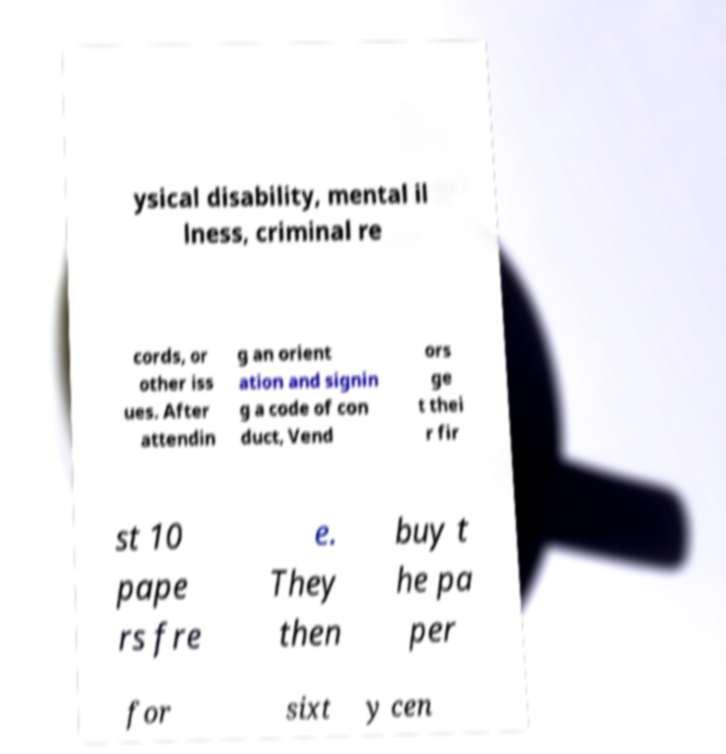I need the written content from this picture converted into text. Can you do that? ysical disability, mental il lness, criminal re cords, or other iss ues. After attendin g an orient ation and signin g a code of con duct, Vend ors ge t thei r fir st 10 pape rs fre e. They then buy t he pa per for sixt y cen 